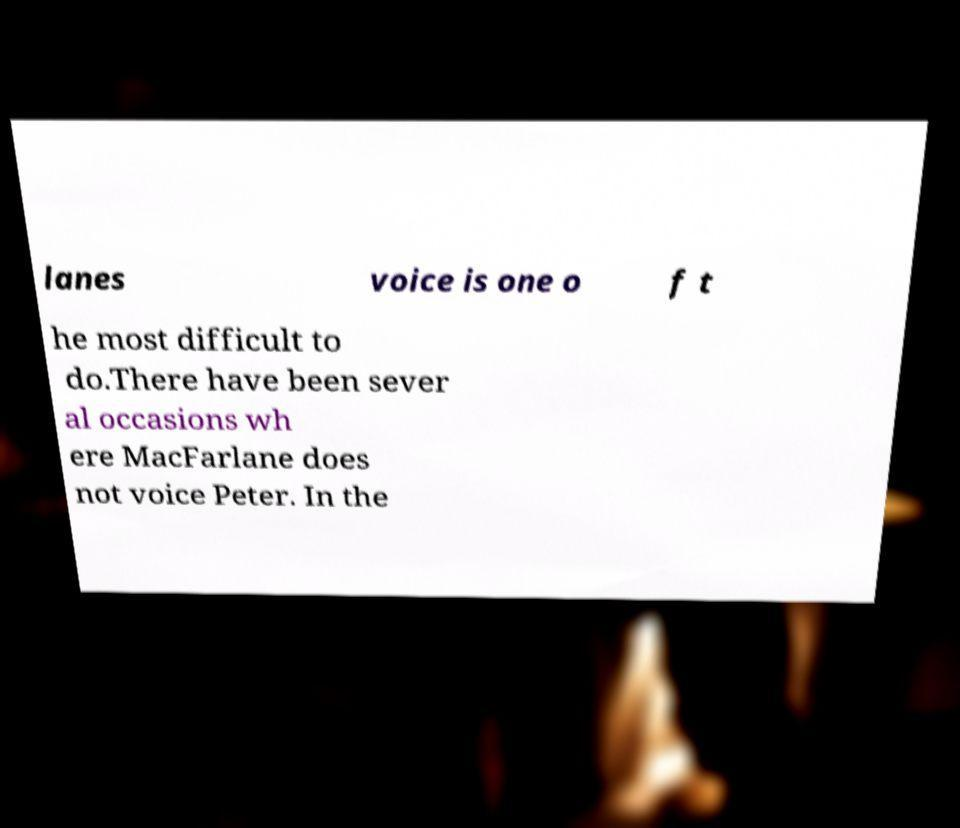Please read and relay the text visible in this image. What does it say? lanes voice is one o f t he most difficult to do.There have been sever al occasions wh ere MacFarlane does not voice Peter. In the 